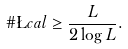Convert formula to latex. <formula><loc_0><loc_0><loc_500><loc_500>\# \L c a l \geq \frac { L } { 2 \log L } .</formula> 